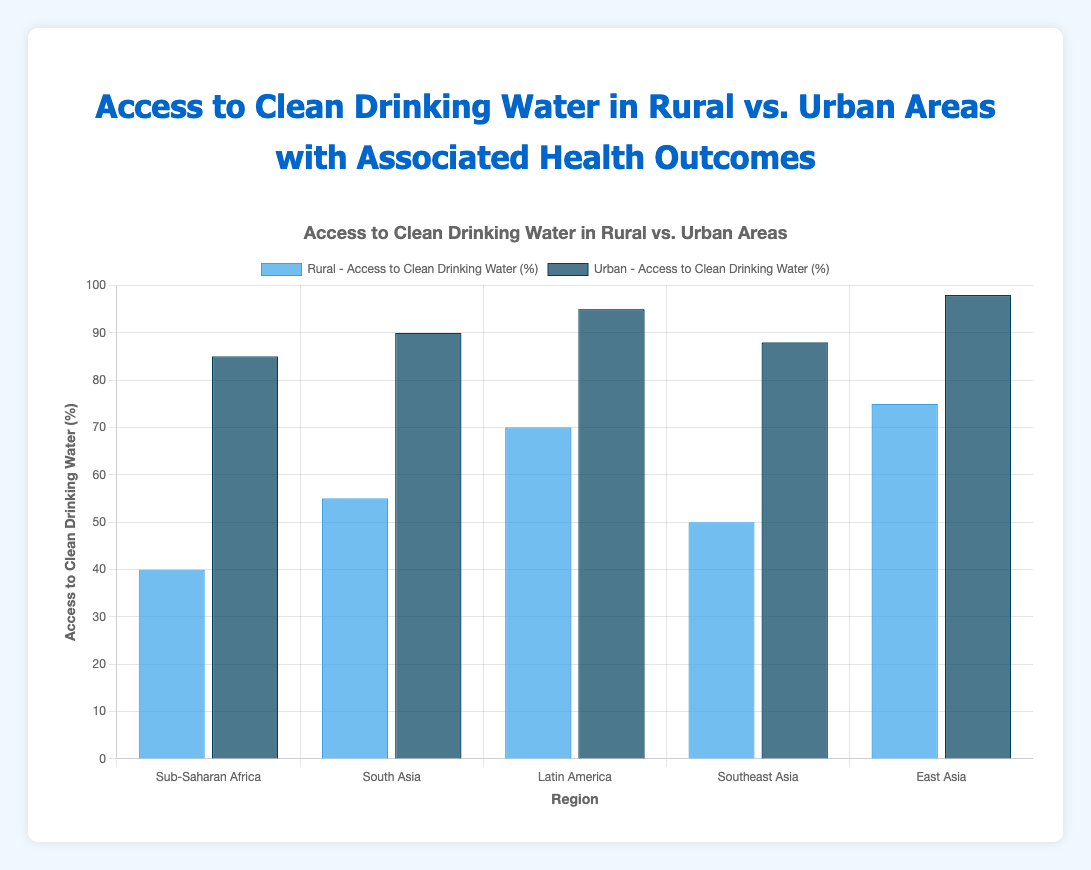What is the difference in access to clean drinking water between rural and urban areas in Sub-Saharan Africa? The access to clean drinking water in rural areas of Sub-Saharan Africa is 40%, while in urban areas it is 85%. The difference is 85% - 40% = 45%.
Answer: 45% Which region shows the highest access to clean drinking water in urban areas? By examining the bars representing urban areas, East Asia has the highest access to clean drinking water at 98%.
Answer: East Asia How many regions have access to clean drinking water above 50% in rural areas? The regions with rural access above 50% are South Asia (55%), Latin America (70%), and East Asia (75%). Counting these regions gives us 3 regions.
Answer: 3 What is the average access to clean drinking water in rural areas across all regions? The values are 40%, 55%, 70%, 50%, and 75%. Summing these yields 40 + 55 + 70 + 50 + 75 = 290. Dividing by 5 gives 290 / 5 = 58%.
Answer: 58% Do rural or urban areas generally have higher access to clean drinking water in the displayed regions? The bars representing urban areas are consistently higher than those representing rural areas, indicating that urban areas generally have higher access to clean drinking water.
Answer: Urban areas Which region has the smallest difference in access to clean drinking water between rural and urban areas? The differences are Sub-Saharan Africa (45%), South Asia (35%), Latin America (25%), Southeast Asia (38%), and East Asia (23%). The smallest difference is in East Asia, with a 23% difference.
Answer: East Asia What is the combined sum of access percentages to clean drinking water in urban areas for South Asia and Latin America? South Asia has 90% and Latin America has 95%. Summing these gives 90 + 95 = 185%.
Answer: 185% Is there a region where rural areas have more than 70% access to clean drinking water? By examining the bars, only East Asia (75%) and Latin America (70%) in rural areas have more than or exactly 70% access.
Answer: Yes How does the access to clean drinking water in urban areas of Southeast Asia compare to rural areas of Sub-Saharan Africa? Urban areas in Southeast Asia have 88% access, while rural areas in Sub-Saharan Africa have 40%. Comparing these, urban Southeast Asia has significantly higher access.
Answer: Urban Southeast Asia is higher What is the visual difference between the bars representing rural areas across all regions? The heights of the bars for rural areas vary, with the lowest being Sub-Saharan Africa at 40% and the highest being East Asia at 75%, showing a wide range of access levels.
Answer: Wide range of heights 